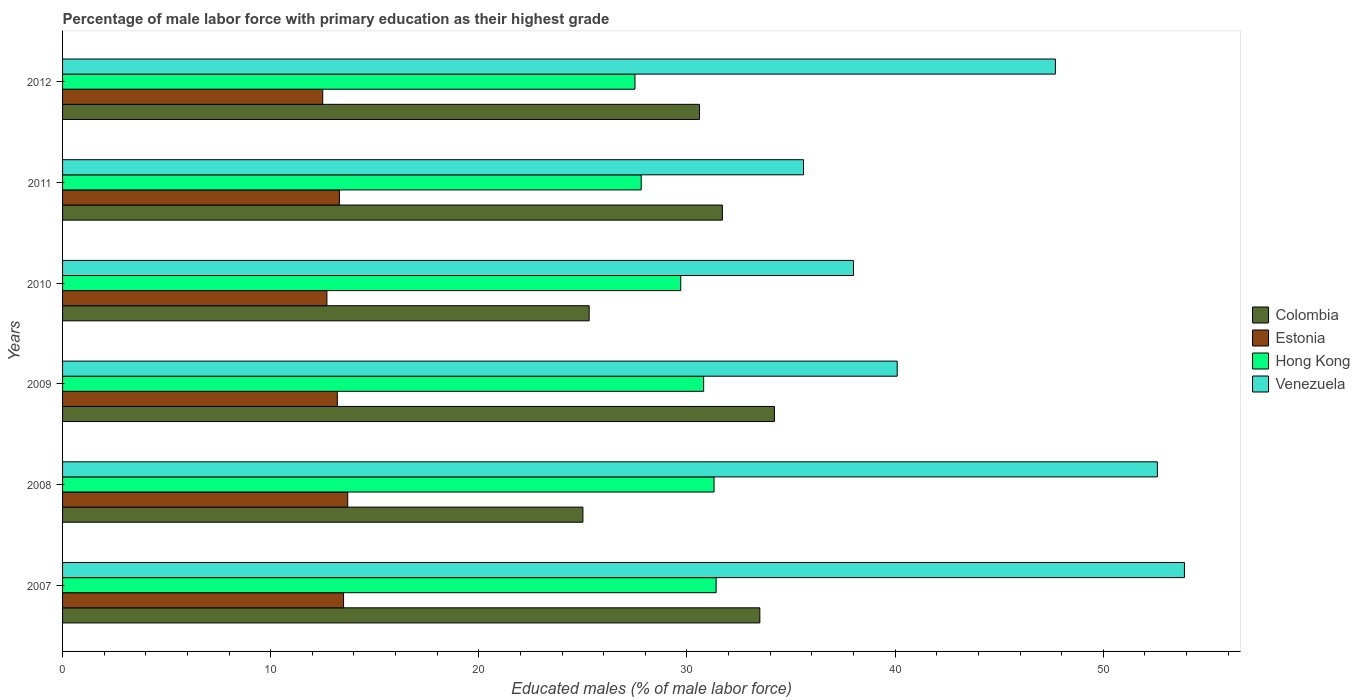How many different coloured bars are there?
Offer a very short reply. 4. How many groups of bars are there?
Make the answer very short. 6. Are the number of bars per tick equal to the number of legend labels?
Provide a short and direct response. Yes. How many bars are there on the 3rd tick from the bottom?
Offer a very short reply. 4. In how many cases, is the number of bars for a given year not equal to the number of legend labels?
Your answer should be very brief. 0. What is the percentage of male labor force with primary education in Venezuela in 2009?
Keep it short and to the point. 40.1. Across all years, what is the maximum percentage of male labor force with primary education in Colombia?
Your answer should be compact. 34.2. Across all years, what is the minimum percentage of male labor force with primary education in Estonia?
Provide a short and direct response. 12.5. In which year was the percentage of male labor force with primary education in Venezuela maximum?
Give a very brief answer. 2007. In which year was the percentage of male labor force with primary education in Hong Kong minimum?
Your answer should be compact. 2012. What is the total percentage of male labor force with primary education in Estonia in the graph?
Your response must be concise. 78.9. What is the difference between the percentage of male labor force with primary education in Hong Kong in 2010 and that in 2012?
Your response must be concise. 2.2. What is the difference between the percentage of male labor force with primary education in Venezuela in 2009 and the percentage of male labor force with primary education in Estonia in 2008?
Your answer should be compact. 26.4. What is the average percentage of male labor force with primary education in Hong Kong per year?
Your response must be concise. 29.75. In the year 2012, what is the difference between the percentage of male labor force with primary education in Hong Kong and percentage of male labor force with primary education in Venezuela?
Your response must be concise. -20.2. What is the ratio of the percentage of male labor force with primary education in Hong Kong in 2007 to that in 2011?
Keep it short and to the point. 1.13. Is the percentage of male labor force with primary education in Venezuela in 2008 less than that in 2010?
Your answer should be compact. No. What is the difference between the highest and the second highest percentage of male labor force with primary education in Venezuela?
Your response must be concise. 1.3. What is the difference between the highest and the lowest percentage of male labor force with primary education in Hong Kong?
Offer a terse response. 3.9. In how many years, is the percentage of male labor force with primary education in Estonia greater than the average percentage of male labor force with primary education in Estonia taken over all years?
Your answer should be compact. 4. Is the sum of the percentage of male labor force with primary education in Hong Kong in 2010 and 2011 greater than the maximum percentage of male labor force with primary education in Colombia across all years?
Your answer should be very brief. Yes. What does the 3rd bar from the top in 2012 represents?
Your answer should be compact. Estonia. Is it the case that in every year, the sum of the percentage of male labor force with primary education in Hong Kong and percentage of male labor force with primary education in Colombia is greater than the percentage of male labor force with primary education in Venezuela?
Keep it short and to the point. Yes. Are all the bars in the graph horizontal?
Your answer should be very brief. Yes. What is the difference between two consecutive major ticks on the X-axis?
Provide a succinct answer. 10. Are the values on the major ticks of X-axis written in scientific E-notation?
Give a very brief answer. No. Does the graph contain any zero values?
Provide a short and direct response. No. Does the graph contain grids?
Your answer should be compact. No. Where does the legend appear in the graph?
Your answer should be compact. Center right. How many legend labels are there?
Keep it short and to the point. 4. How are the legend labels stacked?
Provide a succinct answer. Vertical. What is the title of the graph?
Your answer should be very brief. Percentage of male labor force with primary education as their highest grade. Does "Russian Federation" appear as one of the legend labels in the graph?
Give a very brief answer. No. What is the label or title of the X-axis?
Make the answer very short. Educated males (% of male labor force). What is the Educated males (% of male labor force) of Colombia in 2007?
Your response must be concise. 33.5. What is the Educated males (% of male labor force) of Estonia in 2007?
Make the answer very short. 13.5. What is the Educated males (% of male labor force) in Hong Kong in 2007?
Ensure brevity in your answer.  31.4. What is the Educated males (% of male labor force) of Venezuela in 2007?
Make the answer very short. 53.9. What is the Educated males (% of male labor force) in Colombia in 2008?
Offer a terse response. 25. What is the Educated males (% of male labor force) of Estonia in 2008?
Keep it short and to the point. 13.7. What is the Educated males (% of male labor force) of Hong Kong in 2008?
Provide a succinct answer. 31.3. What is the Educated males (% of male labor force) in Venezuela in 2008?
Your response must be concise. 52.6. What is the Educated males (% of male labor force) of Colombia in 2009?
Offer a terse response. 34.2. What is the Educated males (% of male labor force) of Estonia in 2009?
Your answer should be compact. 13.2. What is the Educated males (% of male labor force) in Hong Kong in 2009?
Offer a very short reply. 30.8. What is the Educated males (% of male labor force) in Venezuela in 2009?
Your response must be concise. 40.1. What is the Educated males (% of male labor force) of Colombia in 2010?
Provide a short and direct response. 25.3. What is the Educated males (% of male labor force) in Estonia in 2010?
Your answer should be compact. 12.7. What is the Educated males (% of male labor force) of Hong Kong in 2010?
Provide a short and direct response. 29.7. What is the Educated males (% of male labor force) in Venezuela in 2010?
Make the answer very short. 38. What is the Educated males (% of male labor force) in Colombia in 2011?
Your response must be concise. 31.7. What is the Educated males (% of male labor force) of Estonia in 2011?
Make the answer very short. 13.3. What is the Educated males (% of male labor force) of Hong Kong in 2011?
Ensure brevity in your answer.  27.8. What is the Educated males (% of male labor force) of Venezuela in 2011?
Your answer should be compact. 35.6. What is the Educated males (% of male labor force) in Colombia in 2012?
Provide a succinct answer. 30.6. What is the Educated males (% of male labor force) of Hong Kong in 2012?
Your answer should be compact. 27.5. What is the Educated males (% of male labor force) of Venezuela in 2012?
Offer a very short reply. 47.7. Across all years, what is the maximum Educated males (% of male labor force) of Colombia?
Offer a terse response. 34.2. Across all years, what is the maximum Educated males (% of male labor force) of Estonia?
Give a very brief answer. 13.7. Across all years, what is the maximum Educated males (% of male labor force) of Hong Kong?
Your answer should be compact. 31.4. Across all years, what is the maximum Educated males (% of male labor force) in Venezuela?
Offer a very short reply. 53.9. Across all years, what is the minimum Educated males (% of male labor force) of Colombia?
Give a very brief answer. 25. Across all years, what is the minimum Educated males (% of male labor force) of Venezuela?
Keep it short and to the point. 35.6. What is the total Educated males (% of male labor force) in Colombia in the graph?
Provide a succinct answer. 180.3. What is the total Educated males (% of male labor force) in Estonia in the graph?
Give a very brief answer. 78.9. What is the total Educated males (% of male labor force) in Hong Kong in the graph?
Provide a succinct answer. 178.5. What is the total Educated males (% of male labor force) of Venezuela in the graph?
Your response must be concise. 267.9. What is the difference between the Educated males (% of male labor force) in Colombia in 2007 and that in 2008?
Provide a succinct answer. 8.5. What is the difference between the Educated males (% of male labor force) of Hong Kong in 2007 and that in 2008?
Your answer should be very brief. 0.1. What is the difference between the Educated males (% of male labor force) of Venezuela in 2007 and that in 2008?
Offer a very short reply. 1.3. What is the difference between the Educated males (% of male labor force) of Colombia in 2007 and that in 2010?
Provide a succinct answer. 8.2. What is the difference between the Educated males (% of male labor force) of Hong Kong in 2007 and that in 2010?
Offer a very short reply. 1.7. What is the difference between the Educated males (% of male labor force) in Venezuela in 2007 and that in 2010?
Make the answer very short. 15.9. What is the difference between the Educated males (% of male labor force) in Colombia in 2007 and that in 2011?
Make the answer very short. 1.8. What is the difference between the Educated males (% of male labor force) of Estonia in 2007 and that in 2011?
Provide a succinct answer. 0.2. What is the difference between the Educated males (% of male labor force) of Colombia in 2007 and that in 2012?
Provide a short and direct response. 2.9. What is the difference between the Educated males (% of male labor force) in Hong Kong in 2007 and that in 2012?
Offer a terse response. 3.9. What is the difference between the Educated males (% of male labor force) of Venezuela in 2007 and that in 2012?
Offer a terse response. 6.2. What is the difference between the Educated males (% of male labor force) in Estonia in 2008 and that in 2009?
Offer a very short reply. 0.5. What is the difference between the Educated males (% of male labor force) in Hong Kong in 2008 and that in 2009?
Your answer should be very brief. 0.5. What is the difference between the Educated males (% of male labor force) in Venezuela in 2008 and that in 2009?
Provide a succinct answer. 12.5. What is the difference between the Educated males (% of male labor force) of Estonia in 2008 and that in 2010?
Your answer should be very brief. 1. What is the difference between the Educated males (% of male labor force) of Hong Kong in 2008 and that in 2010?
Ensure brevity in your answer.  1.6. What is the difference between the Educated males (% of male labor force) in Venezuela in 2008 and that in 2010?
Your answer should be very brief. 14.6. What is the difference between the Educated males (% of male labor force) in Estonia in 2008 and that in 2011?
Give a very brief answer. 0.4. What is the difference between the Educated males (% of male labor force) in Hong Kong in 2008 and that in 2011?
Keep it short and to the point. 3.5. What is the difference between the Educated males (% of male labor force) of Estonia in 2008 and that in 2012?
Provide a succinct answer. 1.2. What is the difference between the Educated males (% of male labor force) of Hong Kong in 2008 and that in 2012?
Make the answer very short. 3.8. What is the difference between the Educated males (% of male labor force) in Estonia in 2009 and that in 2010?
Ensure brevity in your answer.  0.5. What is the difference between the Educated males (% of male labor force) of Venezuela in 2009 and that in 2010?
Ensure brevity in your answer.  2.1. What is the difference between the Educated males (% of male labor force) in Hong Kong in 2009 and that in 2011?
Keep it short and to the point. 3. What is the difference between the Educated males (% of male labor force) in Hong Kong in 2009 and that in 2012?
Offer a very short reply. 3.3. What is the difference between the Educated males (% of male labor force) of Venezuela in 2009 and that in 2012?
Your response must be concise. -7.6. What is the difference between the Educated males (% of male labor force) in Colombia in 2010 and that in 2012?
Make the answer very short. -5.3. What is the difference between the Educated males (% of male labor force) of Estonia in 2010 and that in 2012?
Your answer should be very brief. 0.2. What is the difference between the Educated males (% of male labor force) in Venezuela in 2010 and that in 2012?
Keep it short and to the point. -9.7. What is the difference between the Educated males (% of male labor force) in Colombia in 2011 and that in 2012?
Provide a short and direct response. 1.1. What is the difference between the Educated males (% of male labor force) in Estonia in 2011 and that in 2012?
Provide a succinct answer. 0.8. What is the difference between the Educated males (% of male labor force) in Venezuela in 2011 and that in 2012?
Offer a terse response. -12.1. What is the difference between the Educated males (% of male labor force) of Colombia in 2007 and the Educated males (% of male labor force) of Estonia in 2008?
Ensure brevity in your answer.  19.8. What is the difference between the Educated males (% of male labor force) of Colombia in 2007 and the Educated males (% of male labor force) of Hong Kong in 2008?
Provide a short and direct response. 2.2. What is the difference between the Educated males (% of male labor force) of Colombia in 2007 and the Educated males (% of male labor force) of Venezuela in 2008?
Keep it short and to the point. -19.1. What is the difference between the Educated males (% of male labor force) in Estonia in 2007 and the Educated males (% of male labor force) in Hong Kong in 2008?
Provide a succinct answer. -17.8. What is the difference between the Educated males (% of male labor force) of Estonia in 2007 and the Educated males (% of male labor force) of Venezuela in 2008?
Offer a terse response. -39.1. What is the difference between the Educated males (% of male labor force) of Hong Kong in 2007 and the Educated males (% of male labor force) of Venezuela in 2008?
Offer a very short reply. -21.2. What is the difference between the Educated males (% of male labor force) in Colombia in 2007 and the Educated males (% of male labor force) in Estonia in 2009?
Your answer should be very brief. 20.3. What is the difference between the Educated males (% of male labor force) in Colombia in 2007 and the Educated males (% of male labor force) in Hong Kong in 2009?
Provide a succinct answer. 2.7. What is the difference between the Educated males (% of male labor force) in Colombia in 2007 and the Educated males (% of male labor force) in Venezuela in 2009?
Give a very brief answer. -6.6. What is the difference between the Educated males (% of male labor force) in Estonia in 2007 and the Educated males (% of male labor force) in Hong Kong in 2009?
Give a very brief answer. -17.3. What is the difference between the Educated males (% of male labor force) of Estonia in 2007 and the Educated males (% of male labor force) of Venezuela in 2009?
Your answer should be compact. -26.6. What is the difference between the Educated males (% of male labor force) in Hong Kong in 2007 and the Educated males (% of male labor force) in Venezuela in 2009?
Provide a short and direct response. -8.7. What is the difference between the Educated males (% of male labor force) of Colombia in 2007 and the Educated males (% of male labor force) of Estonia in 2010?
Ensure brevity in your answer.  20.8. What is the difference between the Educated males (% of male labor force) in Colombia in 2007 and the Educated males (% of male labor force) in Venezuela in 2010?
Ensure brevity in your answer.  -4.5. What is the difference between the Educated males (% of male labor force) of Estonia in 2007 and the Educated males (% of male labor force) of Hong Kong in 2010?
Provide a short and direct response. -16.2. What is the difference between the Educated males (% of male labor force) of Estonia in 2007 and the Educated males (% of male labor force) of Venezuela in 2010?
Your response must be concise. -24.5. What is the difference between the Educated males (% of male labor force) of Hong Kong in 2007 and the Educated males (% of male labor force) of Venezuela in 2010?
Your response must be concise. -6.6. What is the difference between the Educated males (% of male labor force) in Colombia in 2007 and the Educated males (% of male labor force) in Estonia in 2011?
Ensure brevity in your answer.  20.2. What is the difference between the Educated males (% of male labor force) in Estonia in 2007 and the Educated males (% of male labor force) in Hong Kong in 2011?
Ensure brevity in your answer.  -14.3. What is the difference between the Educated males (% of male labor force) in Estonia in 2007 and the Educated males (% of male labor force) in Venezuela in 2011?
Provide a succinct answer. -22.1. What is the difference between the Educated males (% of male labor force) in Hong Kong in 2007 and the Educated males (% of male labor force) in Venezuela in 2011?
Your answer should be very brief. -4.2. What is the difference between the Educated males (% of male labor force) of Colombia in 2007 and the Educated males (% of male labor force) of Hong Kong in 2012?
Keep it short and to the point. 6. What is the difference between the Educated males (% of male labor force) in Colombia in 2007 and the Educated males (% of male labor force) in Venezuela in 2012?
Make the answer very short. -14.2. What is the difference between the Educated males (% of male labor force) of Estonia in 2007 and the Educated males (% of male labor force) of Venezuela in 2012?
Ensure brevity in your answer.  -34.2. What is the difference between the Educated males (% of male labor force) in Hong Kong in 2007 and the Educated males (% of male labor force) in Venezuela in 2012?
Your answer should be compact. -16.3. What is the difference between the Educated males (% of male labor force) in Colombia in 2008 and the Educated males (% of male labor force) in Estonia in 2009?
Ensure brevity in your answer.  11.8. What is the difference between the Educated males (% of male labor force) of Colombia in 2008 and the Educated males (% of male labor force) of Hong Kong in 2009?
Your answer should be very brief. -5.8. What is the difference between the Educated males (% of male labor force) of Colombia in 2008 and the Educated males (% of male labor force) of Venezuela in 2009?
Your answer should be compact. -15.1. What is the difference between the Educated males (% of male labor force) in Estonia in 2008 and the Educated males (% of male labor force) in Hong Kong in 2009?
Ensure brevity in your answer.  -17.1. What is the difference between the Educated males (% of male labor force) of Estonia in 2008 and the Educated males (% of male labor force) of Venezuela in 2009?
Make the answer very short. -26.4. What is the difference between the Educated males (% of male labor force) in Colombia in 2008 and the Educated males (% of male labor force) in Venezuela in 2010?
Make the answer very short. -13. What is the difference between the Educated males (% of male labor force) of Estonia in 2008 and the Educated males (% of male labor force) of Hong Kong in 2010?
Offer a terse response. -16. What is the difference between the Educated males (% of male labor force) in Estonia in 2008 and the Educated males (% of male labor force) in Venezuela in 2010?
Your response must be concise. -24.3. What is the difference between the Educated males (% of male labor force) in Hong Kong in 2008 and the Educated males (% of male labor force) in Venezuela in 2010?
Keep it short and to the point. -6.7. What is the difference between the Educated males (% of male labor force) in Colombia in 2008 and the Educated males (% of male labor force) in Estonia in 2011?
Your answer should be compact. 11.7. What is the difference between the Educated males (% of male labor force) in Colombia in 2008 and the Educated males (% of male labor force) in Hong Kong in 2011?
Provide a short and direct response. -2.8. What is the difference between the Educated males (% of male labor force) in Estonia in 2008 and the Educated males (% of male labor force) in Hong Kong in 2011?
Make the answer very short. -14.1. What is the difference between the Educated males (% of male labor force) in Estonia in 2008 and the Educated males (% of male labor force) in Venezuela in 2011?
Offer a very short reply. -21.9. What is the difference between the Educated males (% of male labor force) of Colombia in 2008 and the Educated males (% of male labor force) of Venezuela in 2012?
Your response must be concise. -22.7. What is the difference between the Educated males (% of male labor force) of Estonia in 2008 and the Educated males (% of male labor force) of Venezuela in 2012?
Ensure brevity in your answer.  -34. What is the difference between the Educated males (% of male labor force) of Hong Kong in 2008 and the Educated males (% of male labor force) of Venezuela in 2012?
Your answer should be compact. -16.4. What is the difference between the Educated males (% of male labor force) of Colombia in 2009 and the Educated males (% of male labor force) of Hong Kong in 2010?
Offer a very short reply. 4.5. What is the difference between the Educated males (% of male labor force) in Colombia in 2009 and the Educated males (% of male labor force) in Venezuela in 2010?
Offer a very short reply. -3.8. What is the difference between the Educated males (% of male labor force) of Estonia in 2009 and the Educated males (% of male labor force) of Hong Kong in 2010?
Offer a terse response. -16.5. What is the difference between the Educated males (% of male labor force) of Estonia in 2009 and the Educated males (% of male labor force) of Venezuela in 2010?
Offer a terse response. -24.8. What is the difference between the Educated males (% of male labor force) of Colombia in 2009 and the Educated males (% of male labor force) of Estonia in 2011?
Offer a terse response. 20.9. What is the difference between the Educated males (% of male labor force) in Colombia in 2009 and the Educated males (% of male labor force) in Hong Kong in 2011?
Your answer should be very brief. 6.4. What is the difference between the Educated males (% of male labor force) of Colombia in 2009 and the Educated males (% of male labor force) of Venezuela in 2011?
Keep it short and to the point. -1.4. What is the difference between the Educated males (% of male labor force) in Estonia in 2009 and the Educated males (% of male labor force) in Hong Kong in 2011?
Provide a short and direct response. -14.6. What is the difference between the Educated males (% of male labor force) in Estonia in 2009 and the Educated males (% of male labor force) in Venezuela in 2011?
Give a very brief answer. -22.4. What is the difference between the Educated males (% of male labor force) in Hong Kong in 2009 and the Educated males (% of male labor force) in Venezuela in 2011?
Your response must be concise. -4.8. What is the difference between the Educated males (% of male labor force) of Colombia in 2009 and the Educated males (% of male labor force) of Estonia in 2012?
Provide a succinct answer. 21.7. What is the difference between the Educated males (% of male labor force) in Colombia in 2009 and the Educated males (% of male labor force) in Hong Kong in 2012?
Provide a succinct answer. 6.7. What is the difference between the Educated males (% of male labor force) in Colombia in 2009 and the Educated males (% of male labor force) in Venezuela in 2012?
Give a very brief answer. -13.5. What is the difference between the Educated males (% of male labor force) in Estonia in 2009 and the Educated males (% of male labor force) in Hong Kong in 2012?
Your answer should be compact. -14.3. What is the difference between the Educated males (% of male labor force) in Estonia in 2009 and the Educated males (% of male labor force) in Venezuela in 2012?
Ensure brevity in your answer.  -34.5. What is the difference between the Educated males (% of male labor force) in Hong Kong in 2009 and the Educated males (% of male labor force) in Venezuela in 2012?
Offer a terse response. -16.9. What is the difference between the Educated males (% of male labor force) of Colombia in 2010 and the Educated males (% of male labor force) of Estonia in 2011?
Your response must be concise. 12. What is the difference between the Educated males (% of male labor force) of Colombia in 2010 and the Educated males (% of male labor force) of Hong Kong in 2011?
Your response must be concise. -2.5. What is the difference between the Educated males (% of male labor force) of Estonia in 2010 and the Educated males (% of male labor force) of Hong Kong in 2011?
Ensure brevity in your answer.  -15.1. What is the difference between the Educated males (% of male labor force) of Estonia in 2010 and the Educated males (% of male labor force) of Venezuela in 2011?
Provide a short and direct response. -22.9. What is the difference between the Educated males (% of male labor force) in Colombia in 2010 and the Educated males (% of male labor force) in Estonia in 2012?
Keep it short and to the point. 12.8. What is the difference between the Educated males (% of male labor force) of Colombia in 2010 and the Educated males (% of male labor force) of Hong Kong in 2012?
Provide a succinct answer. -2.2. What is the difference between the Educated males (% of male labor force) in Colombia in 2010 and the Educated males (% of male labor force) in Venezuela in 2012?
Offer a terse response. -22.4. What is the difference between the Educated males (% of male labor force) in Estonia in 2010 and the Educated males (% of male labor force) in Hong Kong in 2012?
Your answer should be compact. -14.8. What is the difference between the Educated males (% of male labor force) of Estonia in 2010 and the Educated males (% of male labor force) of Venezuela in 2012?
Give a very brief answer. -35. What is the difference between the Educated males (% of male labor force) of Hong Kong in 2010 and the Educated males (% of male labor force) of Venezuela in 2012?
Your response must be concise. -18. What is the difference between the Educated males (% of male labor force) in Colombia in 2011 and the Educated males (% of male labor force) in Estonia in 2012?
Offer a terse response. 19.2. What is the difference between the Educated males (% of male labor force) of Colombia in 2011 and the Educated males (% of male labor force) of Hong Kong in 2012?
Your answer should be very brief. 4.2. What is the difference between the Educated males (% of male labor force) in Colombia in 2011 and the Educated males (% of male labor force) in Venezuela in 2012?
Provide a succinct answer. -16. What is the difference between the Educated males (% of male labor force) in Estonia in 2011 and the Educated males (% of male labor force) in Venezuela in 2012?
Give a very brief answer. -34.4. What is the difference between the Educated males (% of male labor force) of Hong Kong in 2011 and the Educated males (% of male labor force) of Venezuela in 2012?
Make the answer very short. -19.9. What is the average Educated males (% of male labor force) of Colombia per year?
Your answer should be very brief. 30.05. What is the average Educated males (% of male labor force) in Estonia per year?
Provide a short and direct response. 13.15. What is the average Educated males (% of male labor force) of Hong Kong per year?
Give a very brief answer. 29.75. What is the average Educated males (% of male labor force) in Venezuela per year?
Provide a short and direct response. 44.65. In the year 2007, what is the difference between the Educated males (% of male labor force) in Colombia and Educated males (% of male labor force) in Hong Kong?
Give a very brief answer. 2.1. In the year 2007, what is the difference between the Educated males (% of male labor force) of Colombia and Educated males (% of male labor force) of Venezuela?
Your answer should be very brief. -20.4. In the year 2007, what is the difference between the Educated males (% of male labor force) of Estonia and Educated males (% of male labor force) of Hong Kong?
Your answer should be compact. -17.9. In the year 2007, what is the difference between the Educated males (% of male labor force) in Estonia and Educated males (% of male labor force) in Venezuela?
Keep it short and to the point. -40.4. In the year 2007, what is the difference between the Educated males (% of male labor force) in Hong Kong and Educated males (% of male labor force) in Venezuela?
Provide a succinct answer. -22.5. In the year 2008, what is the difference between the Educated males (% of male labor force) of Colombia and Educated males (% of male labor force) of Hong Kong?
Your answer should be very brief. -6.3. In the year 2008, what is the difference between the Educated males (% of male labor force) in Colombia and Educated males (% of male labor force) in Venezuela?
Your answer should be very brief. -27.6. In the year 2008, what is the difference between the Educated males (% of male labor force) of Estonia and Educated males (% of male labor force) of Hong Kong?
Offer a terse response. -17.6. In the year 2008, what is the difference between the Educated males (% of male labor force) of Estonia and Educated males (% of male labor force) of Venezuela?
Keep it short and to the point. -38.9. In the year 2008, what is the difference between the Educated males (% of male labor force) in Hong Kong and Educated males (% of male labor force) in Venezuela?
Your response must be concise. -21.3. In the year 2009, what is the difference between the Educated males (% of male labor force) of Colombia and Educated males (% of male labor force) of Estonia?
Give a very brief answer. 21. In the year 2009, what is the difference between the Educated males (% of male labor force) of Colombia and Educated males (% of male labor force) of Hong Kong?
Ensure brevity in your answer.  3.4. In the year 2009, what is the difference between the Educated males (% of male labor force) of Estonia and Educated males (% of male labor force) of Hong Kong?
Give a very brief answer. -17.6. In the year 2009, what is the difference between the Educated males (% of male labor force) in Estonia and Educated males (% of male labor force) in Venezuela?
Make the answer very short. -26.9. In the year 2010, what is the difference between the Educated males (% of male labor force) in Colombia and Educated males (% of male labor force) in Estonia?
Make the answer very short. 12.6. In the year 2010, what is the difference between the Educated males (% of male labor force) in Colombia and Educated males (% of male labor force) in Hong Kong?
Give a very brief answer. -4.4. In the year 2010, what is the difference between the Educated males (% of male labor force) of Colombia and Educated males (% of male labor force) of Venezuela?
Ensure brevity in your answer.  -12.7. In the year 2010, what is the difference between the Educated males (% of male labor force) of Estonia and Educated males (% of male labor force) of Hong Kong?
Your answer should be very brief. -17. In the year 2010, what is the difference between the Educated males (% of male labor force) in Estonia and Educated males (% of male labor force) in Venezuela?
Offer a very short reply. -25.3. In the year 2011, what is the difference between the Educated males (% of male labor force) of Colombia and Educated males (% of male labor force) of Estonia?
Offer a terse response. 18.4. In the year 2011, what is the difference between the Educated males (% of male labor force) in Estonia and Educated males (% of male labor force) in Hong Kong?
Provide a succinct answer. -14.5. In the year 2011, what is the difference between the Educated males (% of male labor force) of Estonia and Educated males (% of male labor force) of Venezuela?
Keep it short and to the point. -22.3. In the year 2012, what is the difference between the Educated males (% of male labor force) of Colombia and Educated males (% of male labor force) of Hong Kong?
Give a very brief answer. 3.1. In the year 2012, what is the difference between the Educated males (% of male labor force) in Colombia and Educated males (% of male labor force) in Venezuela?
Your answer should be very brief. -17.1. In the year 2012, what is the difference between the Educated males (% of male labor force) in Estonia and Educated males (% of male labor force) in Venezuela?
Your answer should be very brief. -35.2. In the year 2012, what is the difference between the Educated males (% of male labor force) in Hong Kong and Educated males (% of male labor force) in Venezuela?
Ensure brevity in your answer.  -20.2. What is the ratio of the Educated males (% of male labor force) of Colombia in 2007 to that in 2008?
Offer a terse response. 1.34. What is the ratio of the Educated males (% of male labor force) in Estonia in 2007 to that in 2008?
Offer a very short reply. 0.99. What is the ratio of the Educated males (% of male labor force) in Hong Kong in 2007 to that in 2008?
Keep it short and to the point. 1. What is the ratio of the Educated males (% of male labor force) of Venezuela in 2007 to that in 2008?
Give a very brief answer. 1.02. What is the ratio of the Educated males (% of male labor force) in Colombia in 2007 to that in 2009?
Ensure brevity in your answer.  0.98. What is the ratio of the Educated males (% of male labor force) in Estonia in 2007 to that in 2009?
Provide a succinct answer. 1.02. What is the ratio of the Educated males (% of male labor force) in Hong Kong in 2007 to that in 2009?
Provide a short and direct response. 1.02. What is the ratio of the Educated males (% of male labor force) in Venezuela in 2007 to that in 2009?
Offer a terse response. 1.34. What is the ratio of the Educated males (% of male labor force) in Colombia in 2007 to that in 2010?
Offer a very short reply. 1.32. What is the ratio of the Educated males (% of male labor force) of Estonia in 2007 to that in 2010?
Your answer should be compact. 1.06. What is the ratio of the Educated males (% of male labor force) in Hong Kong in 2007 to that in 2010?
Ensure brevity in your answer.  1.06. What is the ratio of the Educated males (% of male labor force) in Venezuela in 2007 to that in 2010?
Offer a terse response. 1.42. What is the ratio of the Educated males (% of male labor force) of Colombia in 2007 to that in 2011?
Make the answer very short. 1.06. What is the ratio of the Educated males (% of male labor force) in Estonia in 2007 to that in 2011?
Provide a short and direct response. 1.01. What is the ratio of the Educated males (% of male labor force) of Hong Kong in 2007 to that in 2011?
Ensure brevity in your answer.  1.13. What is the ratio of the Educated males (% of male labor force) in Venezuela in 2007 to that in 2011?
Ensure brevity in your answer.  1.51. What is the ratio of the Educated males (% of male labor force) of Colombia in 2007 to that in 2012?
Your response must be concise. 1.09. What is the ratio of the Educated males (% of male labor force) of Estonia in 2007 to that in 2012?
Offer a terse response. 1.08. What is the ratio of the Educated males (% of male labor force) in Hong Kong in 2007 to that in 2012?
Your response must be concise. 1.14. What is the ratio of the Educated males (% of male labor force) of Venezuela in 2007 to that in 2012?
Offer a terse response. 1.13. What is the ratio of the Educated males (% of male labor force) in Colombia in 2008 to that in 2009?
Ensure brevity in your answer.  0.73. What is the ratio of the Educated males (% of male labor force) in Estonia in 2008 to that in 2009?
Give a very brief answer. 1.04. What is the ratio of the Educated males (% of male labor force) in Hong Kong in 2008 to that in 2009?
Provide a succinct answer. 1.02. What is the ratio of the Educated males (% of male labor force) in Venezuela in 2008 to that in 2009?
Make the answer very short. 1.31. What is the ratio of the Educated males (% of male labor force) of Colombia in 2008 to that in 2010?
Ensure brevity in your answer.  0.99. What is the ratio of the Educated males (% of male labor force) in Estonia in 2008 to that in 2010?
Ensure brevity in your answer.  1.08. What is the ratio of the Educated males (% of male labor force) in Hong Kong in 2008 to that in 2010?
Offer a very short reply. 1.05. What is the ratio of the Educated males (% of male labor force) of Venezuela in 2008 to that in 2010?
Offer a very short reply. 1.38. What is the ratio of the Educated males (% of male labor force) of Colombia in 2008 to that in 2011?
Keep it short and to the point. 0.79. What is the ratio of the Educated males (% of male labor force) of Estonia in 2008 to that in 2011?
Your answer should be compact. 1.03. What is the ratio of the Educated males (% of male labor force) of Hong Kong in 2008 to that in 2011?
Provide a succinct answer. 1.13. What is the ratio of the Educated males (% of male labor force) of Venezuela in 2008 to that in 2011?
Provide a succinct answer. 1.48. What is the ratio of the Educated males (% of male labor force) of Colombia in 2008 to that in 2012?
Offer a very short reply. 0.82. What is the ratio of the Educated males (% of male labor force) in Estonia in 2008 to that in 2012?
Provide a succinct answer. 1.1. What is the ratio of the Educated males (% of male labor force) in Hong Kong in 2008 to that in 2012?
Provide a short and direct response. 1.14. What is the ratio of the Educated males (% of male labor force) in Venezuela in 2008 to that in 2012?
Provide a short and direct response. 1.1. What is the ratio of the Educated males (% of male labor force) in Colombia in 2009 to that in 2010?
Offer a terse response. 1.35. What is the ratio of the Educated males (% of male labor force) in Estonia in 2009 to that in 2010?
Make the answer very short. 1.04. What is the ratio of the Educated males (% of male labor force) in Venezuela in 2009 to that in 2010?
Provide a succinct answer. 1.06. What is the ratio of the Educated males (% of male labor force) in Colombia in 2009 to that in 2011?
Offer a very short reply. 1.08. What is the ratio of the Educated males (% of male labor force) of Estonia in 2009 to that in 2011?
Offer a very short reply. 0.99. What is the ratio of the Educated males (% of male labor force) of Hong Kong in 2009 to that in 2011?
Your response must be concise. 1.11. What is the ratio of the Educated males (% of male labor force) in Venezuela in 2009 to that in 2011?
Give a very brief answer. 1.13. What is the ratio of the Educated males (% of male labor force) in Colombia in 2009 to that in 2012?
Provide a short and direct response. 1.12. What is the ratio of the Educated males (% of male labor force) of Estonia in 2009 to that in 2012?
Provide a short and direct response. 1.06. What is the ratio of the Educated males (% of male labor force) of Hong Kong in 2009 to that in 2012?
Your answer should be compact. 1.12. What is the ratio of the Educated males (% of male labor force) of Venezuela in 2009 to that in 2012?
Your answer should be very brief. 0.84. What is the ratio of the Educated males (% of male labor force) of Colombia in 2010 to that in 2011?
Ensure brevity in your answer.  0.8. What is the ratio of the Educated males (% of male labor force) in Estonia in 2010 to that in 2011?
Your response must be concise. 0.95. What is the ratio of the Educated males (% of male labor force) in Hong Kong in 2010 to that in 2011?
Offer a terse response. 1.07. What is the ratio of the Educated males (% of male labor force) in Venezuela in 2010 to that in 2011?
Offer a very short reply. 1.07. What is the ratio of the Educated males (% of male labor force) of Colombia in 2010 to that in 2012?
Offer a very short reply. 0.83. What is the ratio of the Educated males (% of male labor force) of Hong Kong in 2010 to that in 2012?
Provide a succinct answer. 1.08. What is the ratio of the Educated males (% of male labor force) in Venezuela in 2010 to that in 2012?
Give a very brief answer. 0.8. What is the ratio of the Educated males (% of male labor force) in Colombia in 2011 to that in 2012?
Provide a succinct answer. 1.04. What is the ratio of the Educated males (% of male labor force) in Estonia in 2011 to that in 2012?
Provide a short and direct response. 1.06. What is the ratio of the Educated males (% of male labor force) of Hong Kong in 2011 to that in 2012?
Offer a terse response. 1.01. What is the ratio of the Educated males (% of male labor force) in Venezuela in 2011 to that in 2012?
Keep it short and to the point. 0.75. What is the difference between the highest and the second highest Educated males (% of male labor force) of Colombia?
Provide a succinct answer. 0.7. What is the difference between the highest and the second highest Educated males (% of male labor force) in Estonia?
Offer a very short reply. 0.2. What is the difference between the highest and the second highest Educated males (% of male labor force) of Hong Kong?
Give a very brief answer. 0.1. What is the difference between the highest and the second highest Educated males (% of male labor force) of Venezuela?
Give a very brief answer. 1.3. What is the difference between the highest and the lowest Educated males (% of male labor force) in Colombia?
Provide a succinct answer. 9.2. What is the difference between the highest and the lowest Educated males (% of male labor force) in Estonia?
Ensure brevity in your answer.  1.2. 